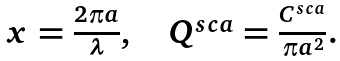Convert formula to latex. <formula><loc_0><loc_0><loc_500><loc_500>\begin{array} { c c c } x = \frac { 2 \pi a } { \lambda } , & \, & Q ^ { s c a } = \frac { C ^ { s c a } } { \pi a ^ { 2 } } . \end{array}</formula> 